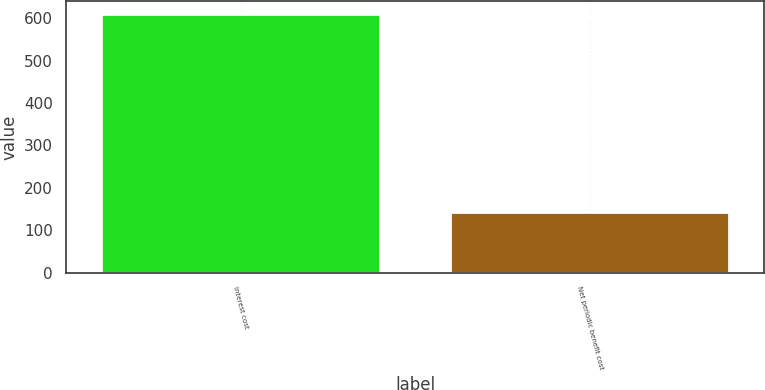<chart> <loc_0><loc_0><loc_500><loc_500><bar_chart><fcel>Interest cost<fcel>Net periodic benefit cost<nl><fcel>609<fcel>144<nl></chart> 